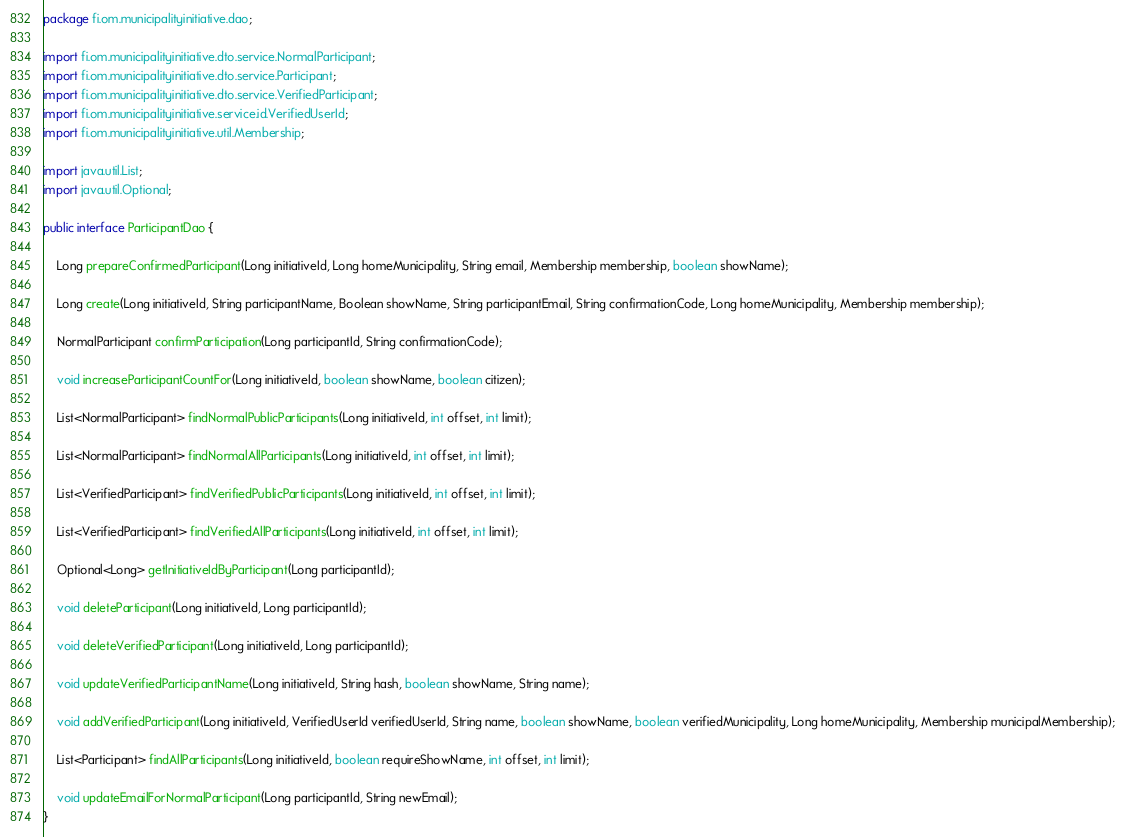<code> <loc_0><loc_0><loc_500><loc_500><_Java_>package fi.om.municipalityinitiative.dao;

import fi.om.municipalityinitiative.dto.service.NormalParticipant;
import fi.om.municipalityinitiative.dto.service.Participant;
import fi.om.municipalityinitiative.dto.service.VerifiedParticipant;
import fi.om.municipalityinitiative.service.id.VerifiedUserId;
import fi.om.municipalityinitiative.util.Membership;

import java.util.List;
import java.util.Optional;

public interface ParticipantDao {

    Long prepareConfirmedParticipant(Long initiativeId, Long homeMunicipality, String email, Membership membership, boolean showName);

    Long create(Long initiativeId, String participantName, Boolean showName, String participantEmail, String confirmationCode, Long homeMunicipality, Membership membership);

    NormalParticipant confirmParticipation(Long participantId, String confirmationCode);

    void increaseParticipantCountFor(Long initiativeId, boolean showName, boolean citizen);

    List<NormalParticipant> findNormalPublicParticipants(Long initiativeId, int offset, int limit);

    List<NormalParticipant> findNormalAllParticipants(Long initiativeId, int offset, int limit);

    List<VerifiedParticipant> findVerifiedPublicParticipants(Long initiativeId, int offset, int limit);

    List<VerifiedParticipant> findVerifiedAllParticipants(Long initiativeId, int offset, int limit);

    Optional<Long> getInitiativeIdByParticipant(Long participantId);

    void deleteParticipant(Long initiativeId, Long participantId);

    void deleteVerifiedParticipant(Long initiativeId, Long participantId);

    void updateVerifiedParticipantName(Long initiativeId, String hash, boolean showName, String name);

    void addVerifiedParticipant(Long initiativeId, VerifiedUserId verifiedUserId, String name, boolean showName, boolean verifiedMunicipality, Long homeMunicipality, Membership municipalMembership);

    List<Participant> findAllParticipants(Long initiativeId, boolean requireShowName, int offset, int limit);

    void updateEmailForNormalParticipant(Long participantId, String newEmail);
}
</code> 